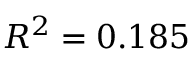Convert formula to latex. <formula><loc_0><loc_0><loc_500><loc_500>R ^ { 2 } = 0 . 1 8 5</formula> 